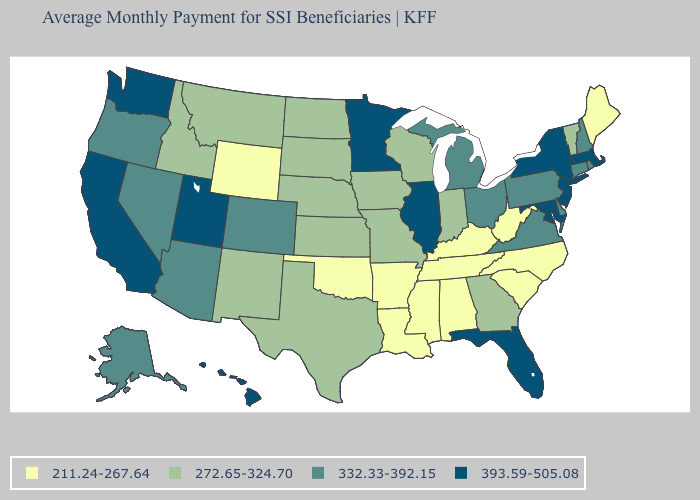What is the value of Utah?
Quick response, please. 393.59-505.08. Name the states that have a value in the range 272.65-324.70?
Answer briefly. Georgia, Idaho, Indiana, Iowa, Kansas, Missouri, Montana, Nebraska, New Mexico, North Dakota, South Dakota, Texas, Vermont, Wisconsin. Which states hav the highest value in the MidWest?
Concise answer only. Illinois, Minnesota. What is the value of Nevada?
Answer briefly. 332.33-392.15. Does Alabama have a lower value than Missouri?
Answer briefly. Yes. Does Pennsylvania have a higher value than Delaware?
Concise answer only. No. Does the first symbol in the legend represent the smallest category?
Concise answer only. Yes. Name the states that have a value in the range 272.65-324.70?
Be succinct. Georgia, Idaho, Indiana, Iowa, Kansas, Missouri, Montana, Nebraska, New Mexico, North Dakota, South Dakota, Texas, Vermont, Wisconsin. Among the states that border Arkansas , which have the highest value?
Give a very brief answer. Missouri, Texas. What is the lowest value in the USA?
Answer briefly. 211.24-267.64. Does the first symbol in the legend represent the smallest category?
Short answer required. Yes. Among the states that border Kentucky , does West Virginia have the highest value?
Concise answer only. No. Name the states that have a value in the range 332.33-392.15?
Answer briefly. Alaska, Arizona, Colorado, Connecticut, Delaware, Michigan, Nevada, New Hampshire, Ohio, Oregon, Pennsylvania, Rhode Island, Virginia. Does Tennessee have a lower value than New Jersey?
Answer briefly. Yes. Among the states that border Illinois , which have the lowest value?
Concise answer only. Kentucky. 